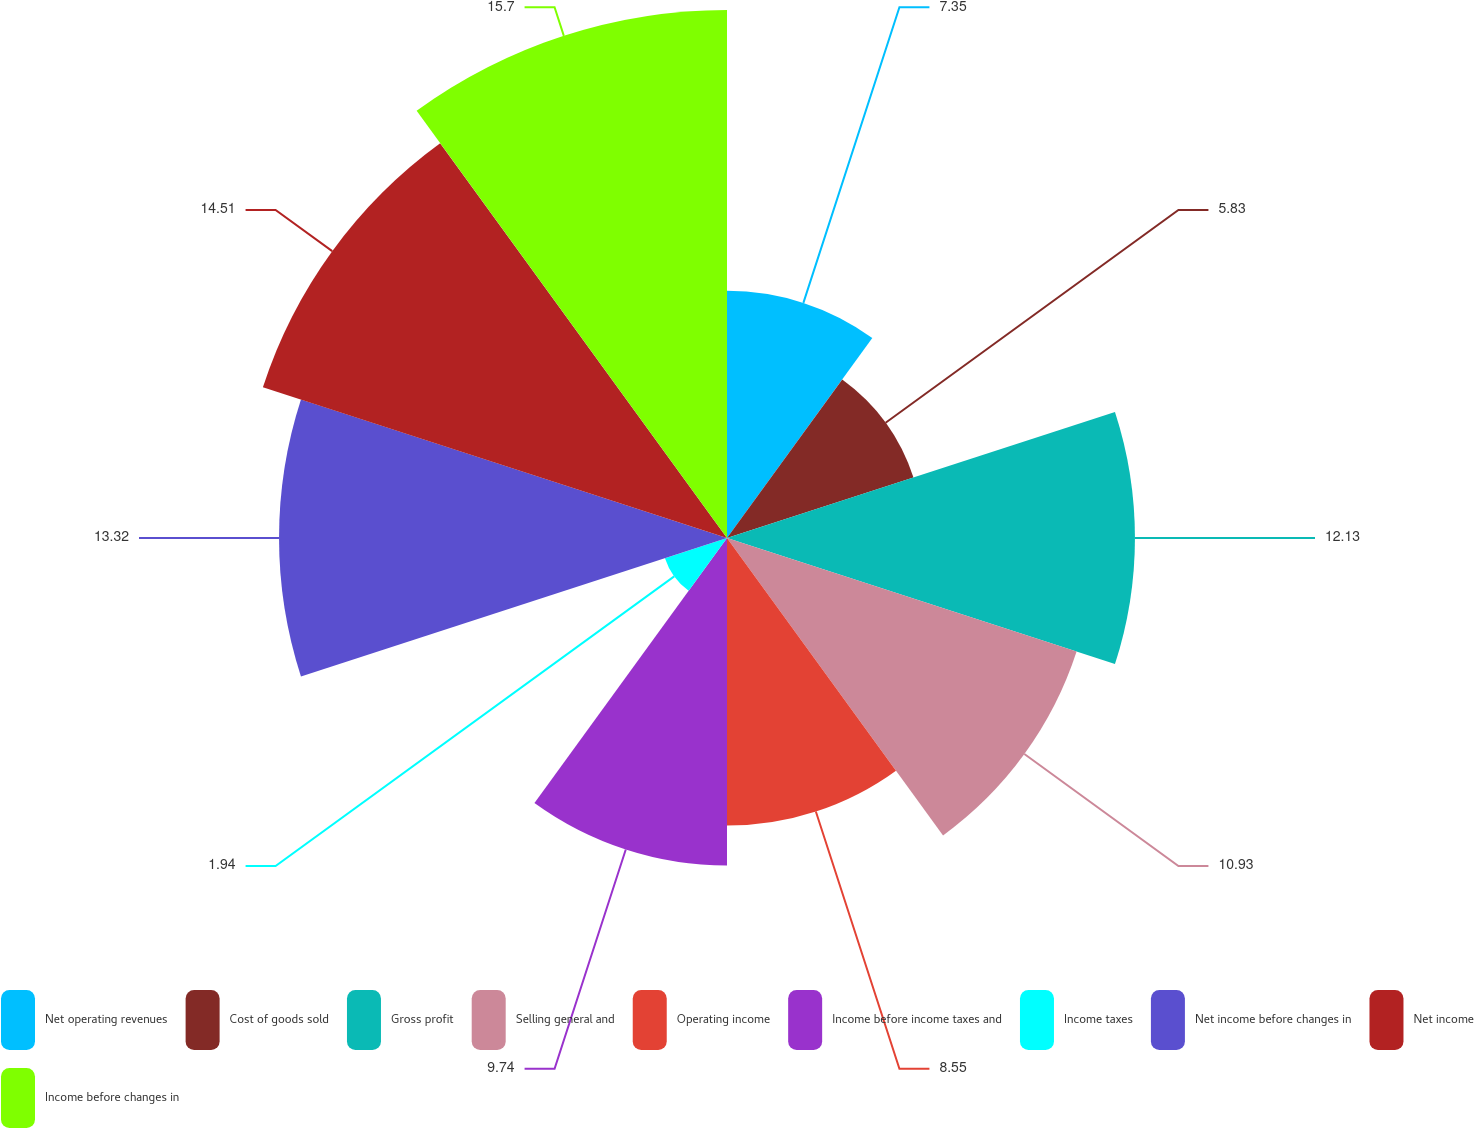<chart> <loc_0><loc_0><loc_500><loc_500><pie_chart><fcel>Net operating revenues<fcel>Cost of goods sold<fcel>Gross profit<fcel>Selling general and<fcel>Operating income<fcel>Income before income taxes and<fcel>Income taxes<fcel>Net income before changes in<fcel>Net income<fcel>Income before changes in<nl><fcel>7.35%<fcel>5.83%<fcel>12.13%<fcel>10.93%<fcel>8.55%<fcel>9.74%<fcel>1.94%<fcel>13.32%<fcel>14.51%<fcel>15.7%<nl></chart> 